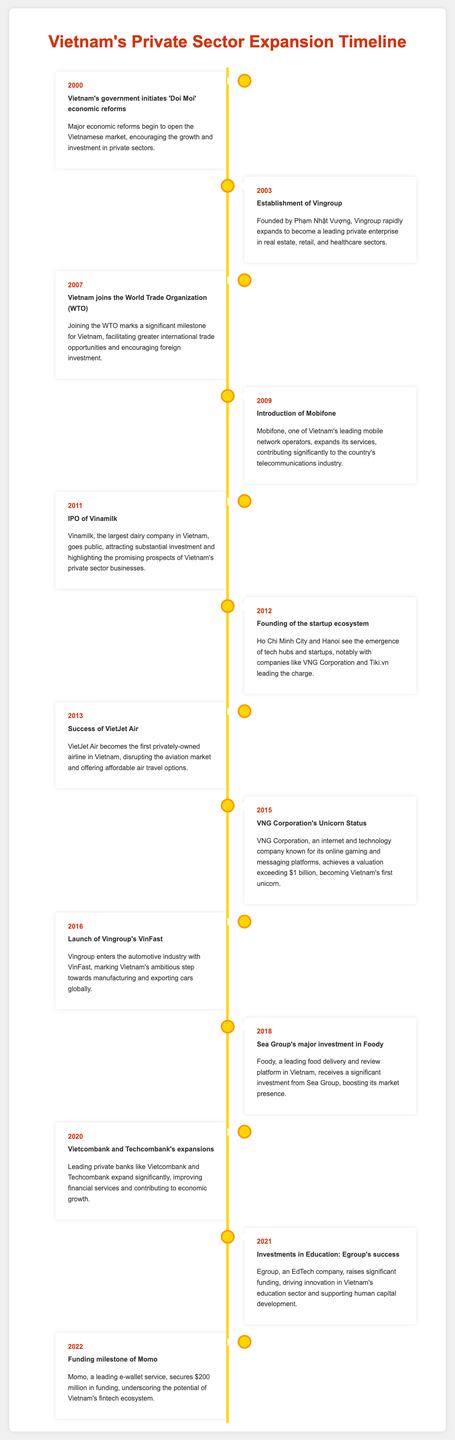what year did Vietnam join the WTO? The document states that Vietnam joined the WTO in the year 2007.
Answer: 2007 who is the founder of Vingroup? The document mentions that Vingroup was founded by Phạm Nhật Vượng.
Answer: Phạm Nhật Vượng what significant funding milestone did Momo achieve in 2022? According to the timeline, Momo secured $200 million in funding in 2022.
Answer: $200 million which company became Vietnam's first unicorn? The document indicates that VNG Corporation achieved unicorn status in 2015.
Answer: VNG Corporation what sector did VietJet Air disrupt? The timeline states that VietJet Air disrupted the aviation market in Vietnam.
Answer: aviation market in what year did the startup ecosystem start emerging in Vietnam? The document notes that the startup ecosystem began to emerge in 2012.
Answer: 2012 what major reform initiated in the year 2000? The document highlights that 'Doi Moi' economic reforms were initiated in 2000.
Answer: 'Doi Moi' economic reforms what type of company is Vinamilk? The timeline describes Vinamilk as the largest dairy company in Vietnam.
Answer: dairy company how much funding did Egroup raise in 2021? The document does not specify the exact amount but indicates that Egroup raised significant funding.
Answer: significant funding 